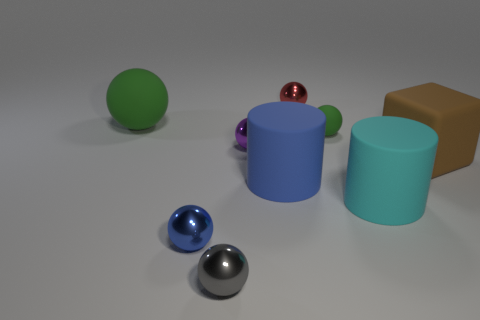What is the size of the blue metal thing that is the same shape as the tiny gray thing?
Your answer should be very brief. Small. Are there any big green rubber balls in front of the block?
Provide a succinct answer. No. Are there an equal number of small purple metallic objects behind the gray sphere and small green rubber cylinders?
Your answer should be very brief. No. Are there any purple spheres that are to the right of the thing that is behind the big thing on the left side of the small blue sphere?
Give a very brief answer. No. What material is the large blue object?
Offer a terse response. Rubber. What number of other things are there of the same shape as the gray object?
Provide a succinct answer. 5. Is the big blue rubber thing the same shape as the tiny gray object?
Offer a terse response. No. What number of objects are either tiny objects that are behind the tiny blue metal object or small blue shiny balls that are behind the tiny gray sphere?
Provide a succinct answer. 4. What number of objects are either tiny red metallic balls or blocks?
Your response must be concise. 2. There is a big object behind the big matte block; what number of gray metal things are behind it?
Your response must be concise. 0. 